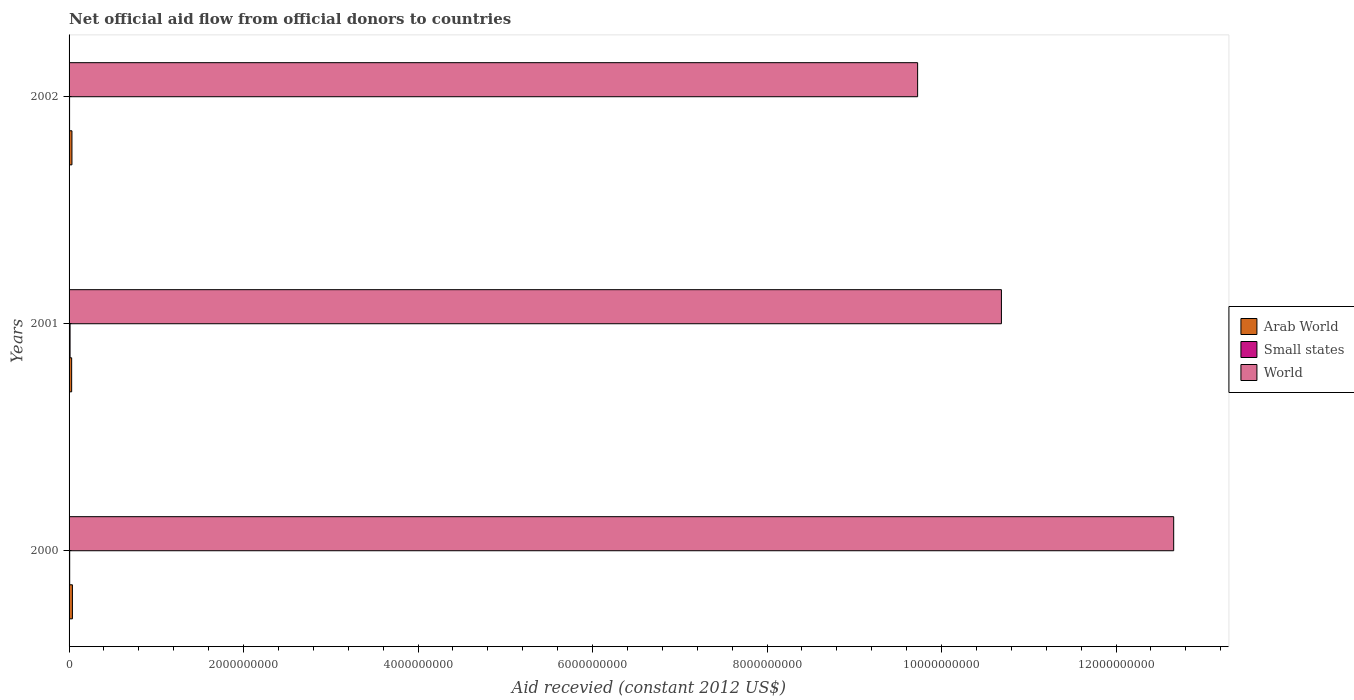Are the number of bars per tick equal to the number of legend labels?
Your response must be concise. Yes. Are the number of bars on each tick of the Y-axis equal?
Ensure brevity in your answer.  Yes. In how many cases, is the number of bars for a given year not equal to the number of legend labels?
Your response must be concise. 0. What is the total aid received in Small states in 2001?
Make the answer very short. 1.14e+07. Across all years, what is the maximum total aid received in World?
Provide a short and direct response. 1.27e+1. Across all years, what is the minimum total aid received in Arab World?
Give a very brief answer. 2.97e+07. What is the total total aid received in World in the graph?
Provide a succinct answer. 3.31e+1. What is the difference between the total aid received in Small states in 2000 and that in 2002?
Make the answer very short. 1.30e+06. What is the difference between the total aid received in World in 2000 and the total aid received in Small states in 2002?
Provide a succinct answer. 1.27e+1. What is the average total aid received in Arab World per year?
Your answer should be very brief. 3.37e+07. In the year 2000, what is the difference between the total aid received in Small states and total aid received in Arab World?
Your answer should be very brief. -3.13e+07. In how many years, is the total aid received in Arab World greater than 2800000000 US$?
Make the answer very short. 0. What is the ratio of the total aid received in Small states in 2001 to that in 2002?
Provide a short and direct response. 1.97. Is the total aid received in Small states in 2000 less than that in 2001?
Ensure brevity in your answer.  Yes. Is the difference between the total aid received in Small states in 2000 and 2002 greater than the difference between the total aid received in Arab World in 2000 and 2002?
Make the answer very short. No. What is the difference between the highest and the second highest total aid received in Small states?
Keep it short and to the point. 4.30e+06. What is the difference between the highest and the lowest total aid received in Arab World?
Offer a very short reply. 8.66e+06. In how many years, is the total aid received in Arab World greater than the average total aid received in Arab World taken over all years?
Offer a very short reply. 1. Is the sum of the total aid received in Small states in 2000 and 2002 greater than the maximum total aid received in Arab World across all years?
Your response must be concise. No. What does the 1st bar from the bottom in 2000 represents?
Provide a short and direct response. Arab World. How many bars are there?
Provide a short and direct response. 9. Are all the bars in the graph horizontal?
Provide a succinct answer. Yes. What is the difference between two consecutive major ticks on the X-axis?
Keep it short and to the point. 2.00e+09. Are the values on the major ticks of X-axis written in scientific E-notation?
Make the answer very short. No. Does the graph contain any zero values?
Provide a succinct answer. No. How many legend labels are there?
Your answer should be compact. 3. How are the legend labels stacked?
Offer a terse response. Vertical. What is the title of the graph?
Your response must be concise. Net official aid flow from official donors to countries. Does "Aruba" appear as one of the legend labels in the graph?
Ensure brevity in your answer.  No. What is the label or title of the X-axis?
Your response must be concise. Aid recevied (constant 2012 US$). What is the label or title of the Y-axis?
Your answer should be compact. Years. What is the Aid recevied (constant 2012 US$) in Arab World in 2000?
Keep it short and to the point. 3.84e+07. What is the Aid recevied (constant 2012 US$) of Small states in 2000?
Your response must be concise. 7.08e+06. What is the Aid recevied (constant 2012 US$) in World in 2000?
Keep it short and to the point. 1.27e+1. What is the Aid recevied (constant 2012 US$) in Arab World in 2001?
Give a very brief answer. 2.97e+07. What is the Aid recevied (constant 2012 US$) of Small states in 2001?
Provide a succinct answer. 1.14e+07. What is the Aid recevied (constant 2012 US$) in World in 2001?
Keep it short and to the point. 1.07e+1. What is the Aid recevied (constant 2012 US$) in Arab World in 2002?
Ensure brevity in your answer.  3.30e+07. What is the Aid recevied (constant 2012 US$) in Small states in 2002?
Ensure brevity in your answer.  5.78e+06. What is the Aid recevied (constant 2012 US$) of World in 2002?
Offer a very short reply. 9.73e+09. Across all years, what is the maximum Aid recevied (constant 2012 US$) of Arab World?
Offer a terse response. 3.84e+07. Across all years, what is the maximum Aid recevied (constant 2012 US$) in Small states?
Provide a succinct answer. 1.14e+07. Across all years, what is the maximum Aid recevied (constant 2012 US$) in World?
Provide a short and direct response. 1.27e+1. Across all years, what is the minimum Aid recevied (constant 2012 US$) in Arab World?
Ensure brevity in your answer.  2.97e+07. Across all years, what is the minimum Aid recevied (constant 2012 US$) of Small states?
Your answer should be compact. 5.78e+06. Across all years, what is the minimum Aid recevied (constant 2012 US$) of World?
Ensure brevity in your answer.  9.73e+09. What is the total Aid recevied (constant 2012 US$) in Arab World in the graph?
Provide a succinct answer. 1.01e+08. What is the total Aid recevied (constant 2012 US$) in Small states in the graph?
Provide a succinct answer. 2.42e+07. What is the total Aid recevied (constant 2012 US$) in World in the graph?
Ensure brevity in your answer.  3.31e+1. What is the difference between the Aid recevied (constant 2012 US$) in Arab World in 2000 and that in 2001?
Keep it short and to the point. 8.66e+06. What is the difference between the Aid recevied (constant 2012 US$) of Small states in 2000 and that in 2001?
Your answer should be very brief. -4.30e+06. What is the difference between the Aid recevied (constant 2012 US$) of World in 2000 and that in 2001?
Provide a succinct answer. 1.97e+09. What is the difference between the Aid recevied (constant 2012 US$) in Arab World in 2000 and that in 2002?
Offer a very short reply. 5.31e+06. What is the difference between the Aid recevied (constant 2012 US$) in Small states in 2000 and that in 2002?
Give a very brief answer. 1.30e+06. What is the difference between the Aid recevied (constant 2012 US$) of World in 2000 and that in 2002?
Your answer should be very brief. 2.93e+09. What is the difference between the Aid recevied (constant 2012 US$) of Arab World in 2001 and that in 2002?
Provide a succinct answer. -3.35e+06. What is the difference between the Aid recevied (constant 2012 US$) of Small states in 2001 and that in 2002?
Provide a short and direct response. 5.60e+06. What is the difference between the Aid recevied (constant 2012 US$) of World in 2001 and that in 2002?
Your answer should be compact. 9.60e+08. What is the difference between the Aid recevied (constant 2012 US$) of Arab World in 2000 and the Aid recevied (constant 2012 US$) of Small states in 2001?
Offer a very short reply. 2.70e+07. What is the difference between the Aid recevied (constant 2012 US$) in Arab World in 2000 and the Aid recevied (constant 2012 US$) in World in 2001?
Keep it short and to the point. -1.06e+1. What is the difference between the Aid recevied (constant 2012 US$) in Small states in 2000 and the Aid recevied (constant 2012 US$) in World in 2001?
Provide a succinct answer. -1.07e+1. What is the difference between the Aid recevied (constant 2012 US$) in Arab World in 2000 and the Aid recevied (constant 2012 US$) in Small states in 2002?
Your answer should be compact. 3.26e+07. What is the difference between the Aid recevied (constant 2012 US$) of Arab World in 2000 and the Aid recevied (constant 2012 US$) of World in 2002?
Make the answer very short. -9.69e+09. What is the difference between the Aid recevied (constant 2012 US$) in Small states in 2000 and the Aid recevied (constant 2012 US$) in World in 2002?
Provide a short and direct response. -9.72e+09. What is the difference between the Aid recevied (constant 2012 US$) in Arab World in 2001 and the Aid recevied (constant 2012 US$) in Small states in 2002?
Ensure brevity in your answer.  2.39e+07. What is the difference between the Aid recevied (constant 2012 US$) of Arab World in 2001 and the Aid recevied (constant 2012 US$) of World in 2002?
Ensure brevity in your answer.  -9.70e+09. What is the difference between the Aid recevied (constant 2012 US$) of Small states in 2001 and the Aid recevied (constant 2012 US$) of World in 2002?
Keep it short and to the point. -9.71e+09. What is the average Aid recevied (constant 2012 US$) in Arab World per year?
Ensure brevity in your answer.  3.37e+07. What is the average Aid recevied (constant 2012 US$) of Small states per year?
Offer a very short reply. 8.08e+06. What is the average Aid recevied (constant 2012 US$) in World per year?
Provide a succinct answer. 1.10e+1. In the year 2000, what is the difference between the Aid recevied (constant 2012 US$) in Arab World and Aid recevied (constant 2012 US$) in Small states?
Your answer should be compact. 3.13e+07. In the year 2000, what is the difference between the Aid recevied (constant 2012 US$) in Arab World and Aid recevied (constant 2012 US$) in World?
Ensure brevity in your answer.  -1.26e+1. In the year 2000, what is the difference between the Aid recevied (constant 2012 US$) of Small states and Aid recevied (constant 2012 US$) of World?
Provide a short and direct response. -1.27e+1. In the year 2001, what is the difference between the Aid recevied (constant 2012 US$) of Arab World and Aid recevied (constant 2012 US$) of Small states?
Give a very brief answer. 1.83e+07. In the year 2001, what is the difference between the Aid recevied (constant 2012 US$) of Arab World and Aid recevied (constant 2012 US$) of World?
Offer a terse response. -1.07e+1. In the year 2001, what is the difference between the Aid recevied (constant 2012 US$) of Small states and Aid recevied (constant 2012 US$) of World?
Provide a short and direct response. -1.07e+1. In the year 2002, what is the difference between the Aid recevied (constant 2012 US$) in Arab World and Aid recevied (constant 2012 US$) in Small states?
Make the answer very short. 2.73e+07. In the year 2002, what is the difference between the Aid recevied (constant 2012 US$) in Arab World and Aid recevied (constant 2012 US$) in World?
Provide a short and direct response. -9.69e+09. In the year 2002, what is the difference between the Aid recevied (constant 2012 US$) in Small states and Aid recevied (constant 2012 US$) in World?
Offer a terse response. -9.72e+09. What is the ratio of the Aid recevied (constant 2012 US$) in Arab World in 2000 to that in 2001?
Your answer should be compact. 1.29. What is the ratio of the Aid recevied (constant 2012 US$) of Small states in 2000 to that in 2001?
Offer a very short reply. 0.62. What is the ratio of the Aid recevied (constant 2012 US$) of World in 2000 to that in 2001?
Provide a succinct answer. 1.18. What is the ratio of the Aid recevied (constant 2012 US$) of Arab World in 2000 to that in 2002?
Offer a very short reply. 1.16. What is the ratio of the Aid recevied (constant 2012 US$) of Small states in 2000 to that in 2002?
Offer a terse response. 1.22. What is the ratio of the Aid recevied (constant 2012 US$) of World in 2000 to that in 2002?
Provide a succinct answer. 1.3. What is the ratio of the Aid recevied (constant 2012 US$) of Arab World in 2001 to that in 2002?
Ensure brevity in your answer.  0.9. What is the ratio of the Aid recevied (constant 2012 US$) of Small states in 2001 to that in 2002?
Provide a short and direct response. 1.97. What is the ratio of the Aid recevied (constant 2012 US$) of World in 2001 to that in 2002?
Offer a very short reply. 1.1. What is the difference between the highest and the second highest Aid recevied (constant 2012 US$) in Arab World?
Provide a succinct answer. 5.31e+06. What is the difference between the highest and the second highest Aid recevied (constant 2012 US$) of Small states?
Offer a terse response. 4.30e+06. What is the difference between the highest and the second highest Aid recevied (constant 2012 US$) of World?
Make the answer very short. 1.97e+09. What is the difference between the highest and the lowest Aid recevied (constant 2012 US$) of Arab World?
Offer a very short reply. 8.66e+06. What is the difference between the highest and the lowest Aid recevied (constant 2012 US$) in Small states?
Your response must be concise. 5.60e+06. What is the difference between the highest and the lowest Aid recevied (constant 2012 US$) of World?
Offer a terse response. 2.93e+09. 